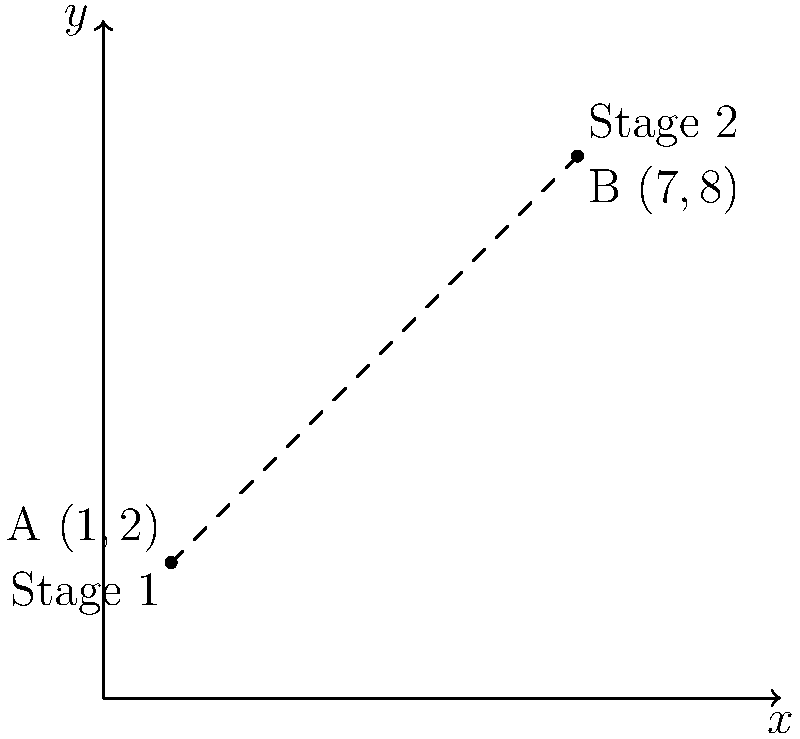As the owner of a popular music venue, you're planning a multi-stage concert layout. Stage 1 is located at coordinates (1,2) and Stage 2 is at (7,8) on your venue map. What is the straight-line distance between these two stages? Use the distance formula and round your answer to two decimal places. To find the distance between two points, we use the distance formula:

$d = \sqrt{(x_2 - x_1)^2 + (y_2 - y_1)^2}$

Where $(x_1, y_1)$ are the coordinates of the first point and $(x_2, y_2)$ are the coordinates of the second point.

Given:
Stage 1: $(x_1, y_1) = (1, 2)$
Stage 2: $(x_2, y_2) = (7, 8)$

Let's plug these into the formula:

$d = \sqrt{(7 - 1)^2 + (8 - 2)^2}$

Simplify inside the parentheses:
$d = \sqrt{(6)^2 + (6)^2}$

Calculate the squares:
$d = \sqrt{36 + 36}$

Add under the square root:
$d = \sqrt{72}$

Simplify:
$d = 6\sqrt{2} \approx 8.48528137...$

Rounding to two decimal places:
$d \approx 8.49$

Therefore, the distance between Stage 1 and Stage 2 is approximately 8.49 units on your venue map.
Answer: 8.49 units 